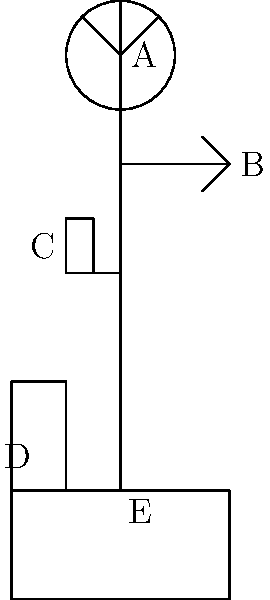In the illustrated weather station setup, which component (labeled A, B, C, D, or E) is most likely to cause ergonomic strain for a meteorologist during regular maintenance, and why? To answer this question, we need to consider the ergonomic implications of each component:

1. A (Anemometer): Located at the top of the pole, height may cause strain when servicing.
2. B (Wind vane): Also high up, but slightly lower than the anemometer.
3. C (Temperature sensor): At a more comfortable height for maintenance.
4. D (Precipitation gauge): Low to the ground, easy to access.
5. E (Base/Main pole): Requires bending to access but not frequent maintenance.

The anemometer (A) is most likely to cause ergonomic strain because:

1. It's at the highest point, requiring extended reaching or climbing.
2. Its position increases risk of falls or overextension.
3. Frequent maintenance is needed due to moving parts and exposure.
4. Working at height often requires awkward postures.
5. Weather conditions at that height can be more severe, increasing difficulty.

While other components may have ergonomic considerations, the anemometer's height and maintenance frequency make it the most problematic from an ergonomic standpoint.
Answer: A (Anemometer) 